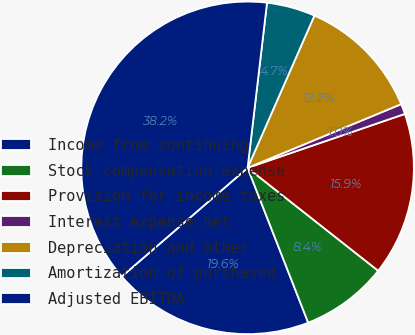Convert chart. <chart><loc_0><loc_0><loc_500><loc_500><pie_chart><fcel>Income from continuing<fcel>Stock compensation expense<fcel>Provision for income taxes<fcel>Interest expense net<fcel>Depreciation and other<fcel>Amortization of purchased<fcel>Adjusted EBITDA<nl><fcel>19.6%<fcel>8.44%<fcel>15.88%<fcel>1.0%<fcel>12.16%<fcel>4.72%<fcel>38.2%<nl></chart> 